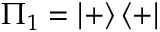Convert formula to latex. <formula><loc_0><loc_0><loc_500><loc_500>\Pi _ { 1 } = \left | + \right \rangle \left \langle + \right |</formula> 